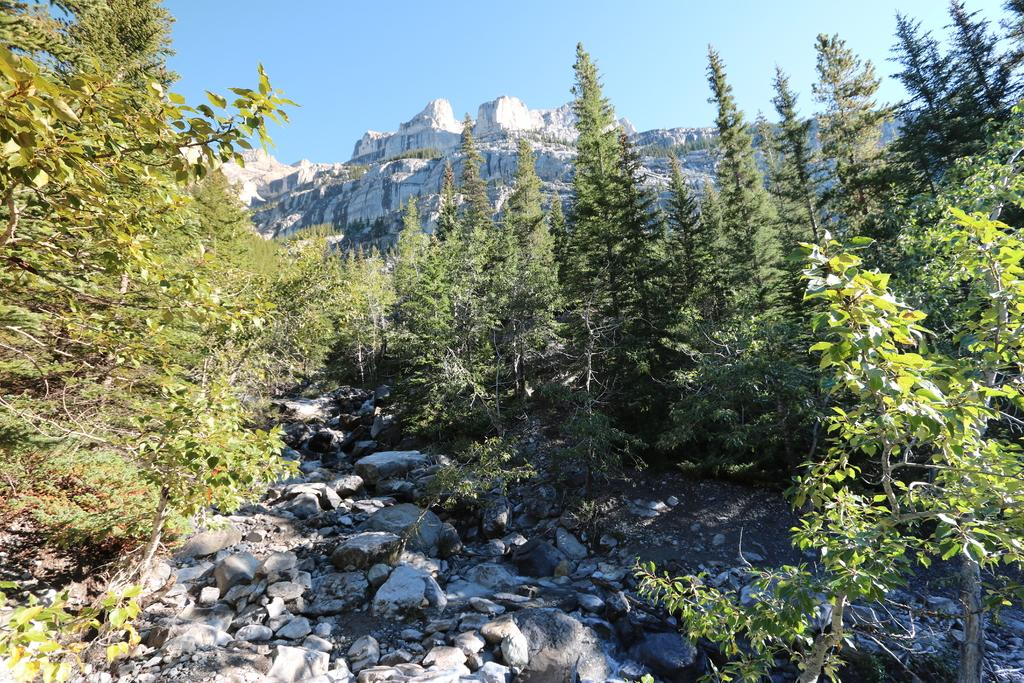What type of natural elements can be seen in the image? There are trees and rocks in the image. What geographical features are present in the image? There are hills in the image. Who is the owner of the event taking place in the image? There is no event or owner mentioned in the image; it only features trees, rocks, and hills. 